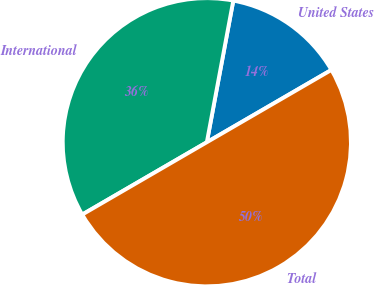Convert chart. <chart><loc_0><loc_0><loc_500><loc_500><pie_chart><fcel>United States<fcel>International<fcel>Total<nl><fcel>13.69%<fcel>36.31%<fcel>50.0%<nl></chart> 